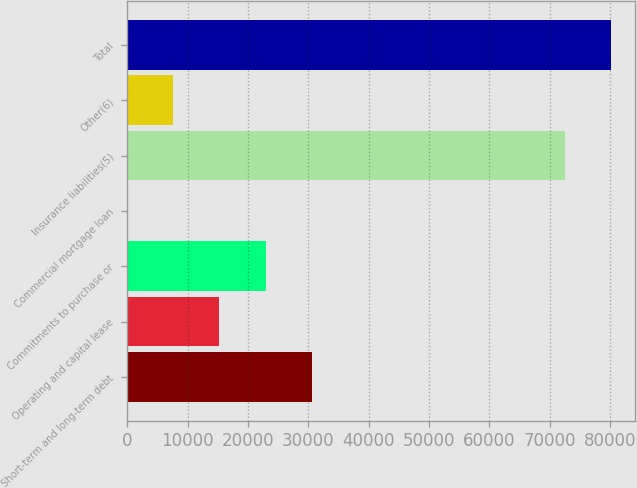Convert chart. <chart><loc_0><loc_0><loc_500><loc_500><bar_chart><fcel>Short-term and long-term debt<fcel>Operating and capital lease<fcel>Commitments to purchase or<fcel>Commercial mortgage loan<fcel>Insurance liabilities(5)<fcel>Other(6)<fcel>Total<nl><fcel>30538.9<fcel>15270.9<fcel>22904.9<fcel>2.83<fcel>72569<fcel>7636.85<fcel>80203<nl></chart> 